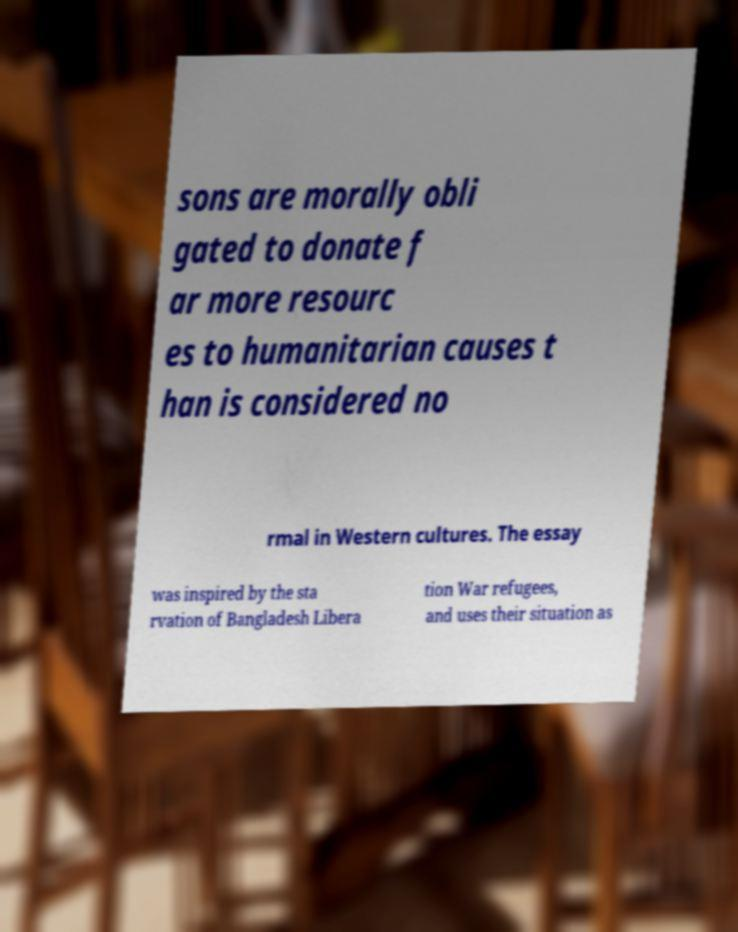Could you assist in decoding the text presented in this image and type it out clearly? sons are morally obli gated to donate f ar more resourc es to humanitarian causes t han is considered no rmal in Western cultures. The essay was inspired by the sta rvation of Bangladesh Libera tion War refugees, and uses their situation as 